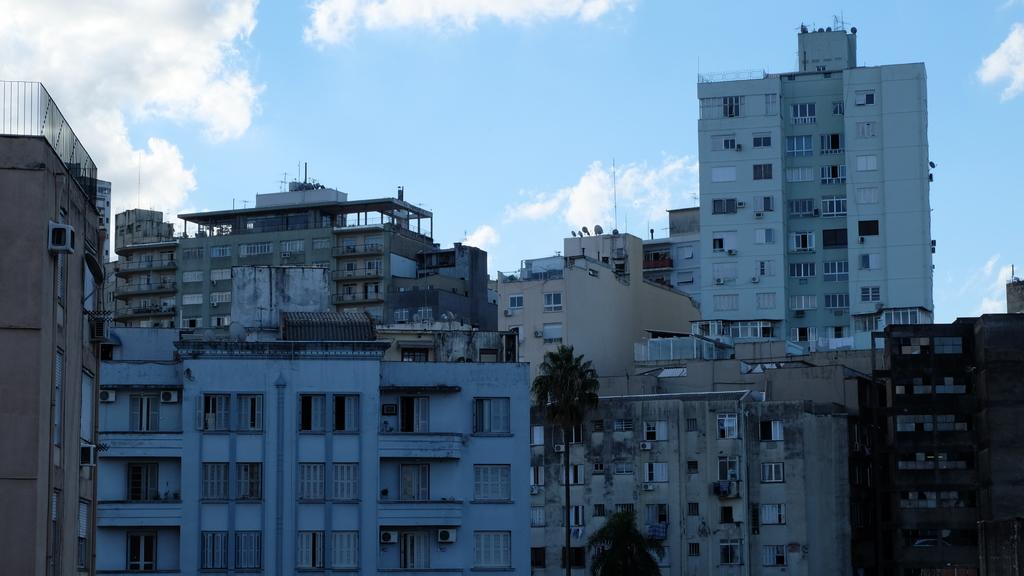Could you give a brief overview of what you see in this image? In this image there are buildings, trees and sky. 